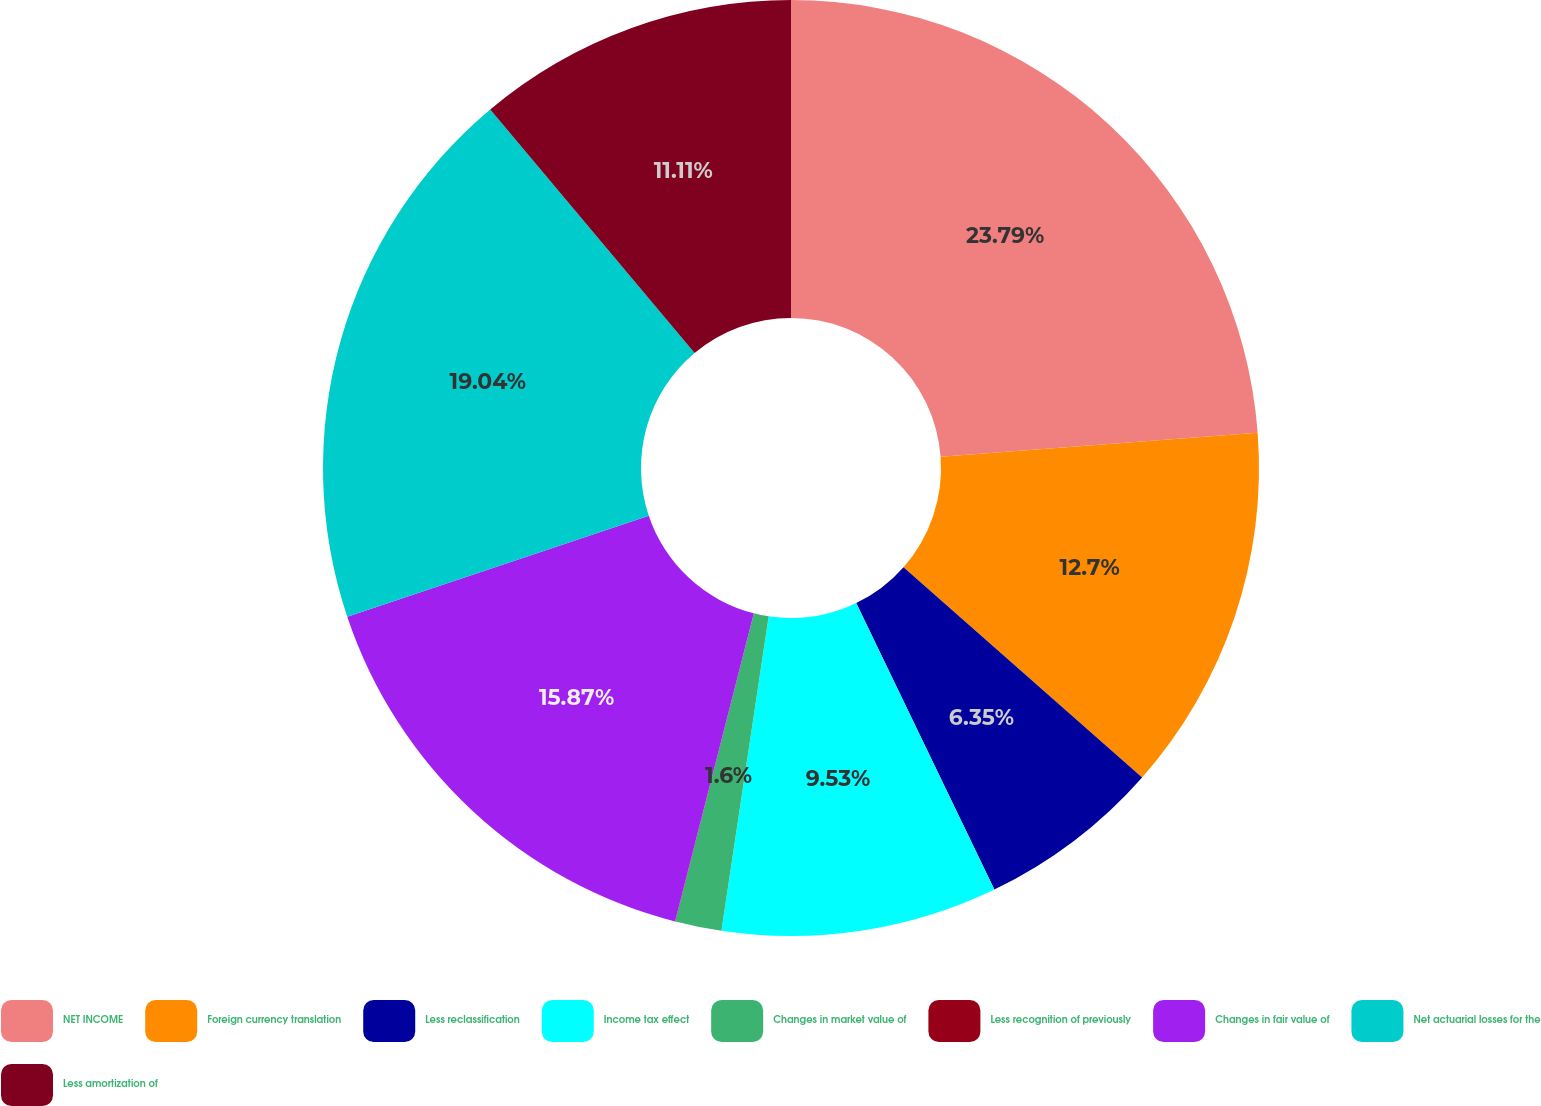Convert chart to OTSL. <chart><loc_0><loc_0><loc_500><loc_500><pie_chart><fcel>NET INCOME<fcel>Foreign currency translation<fcel>Less reclassification<fcel>Income tax effect<fcel>Changes in market value of<fcel>Less recognition of previously<fcel>Changes in fair value of<fcel>Net actuarial losses for the<fcel>Less amortization of<nl><fcel>23.8%<fcel>12.7%<fcel>6.35%<fcel>9.53%<fcel>1.6%<fcel>0.01%<fcel>15.87%<fcel>19.04%<fcel>11.11%<nl></chart> 